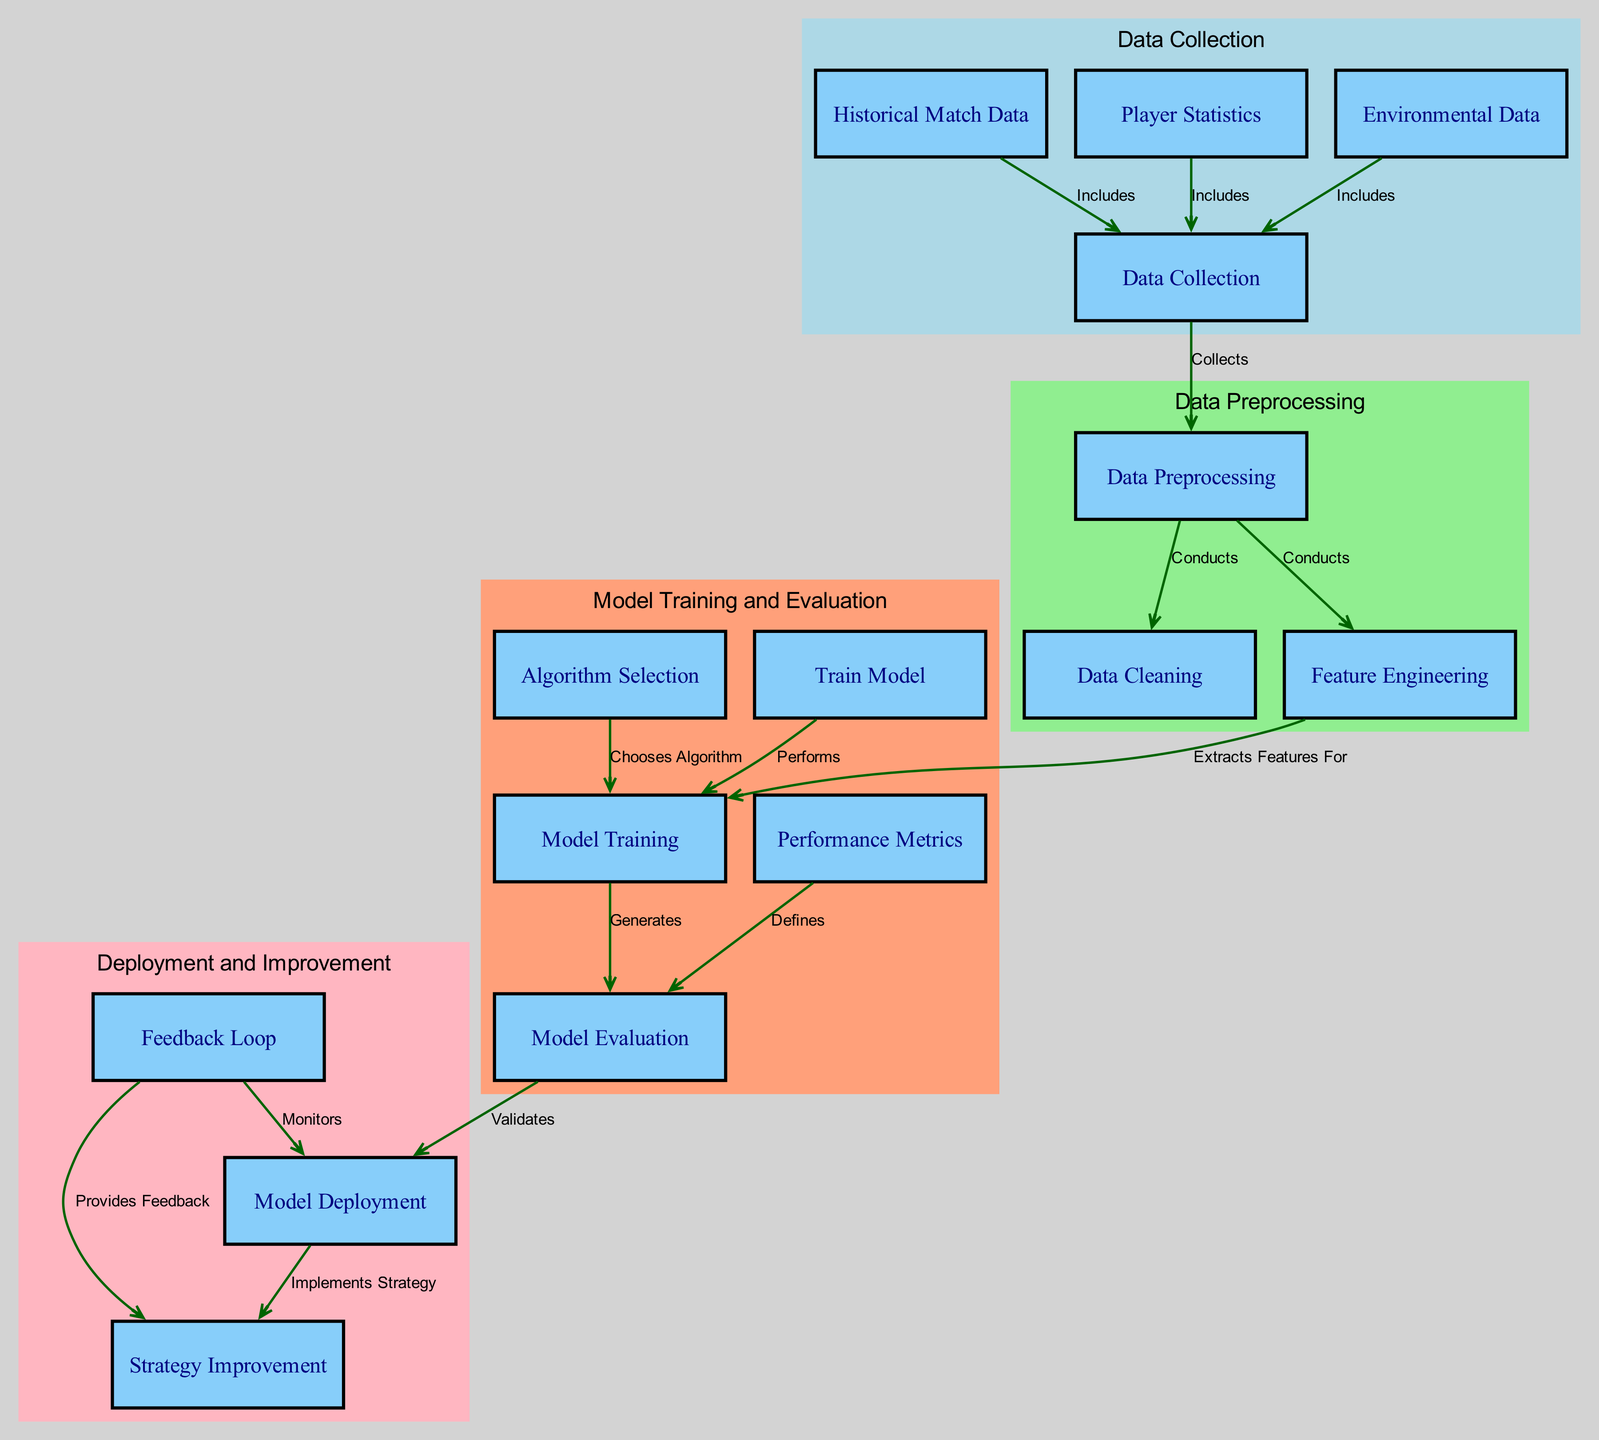What is the first step in the process? The first step in the process is Data Collection, which is where data from various sources like historical match data, player statistics, and environmental data is gathered.
Answer: Data Collection How many nodes are present in the diagram? The diagram contains a total of 14 nodes, each representing a specific stage in the machine learning process for game strategy improvement.
Answer: 14 Which node conducts data cleaning? The node that conducts data cleaning is Data Preprocessing, which is responsible for cleaning the raw data before feature extraction.
Answer: Data Preprocessing What node is responsible for selecting the algorithm? The node that is responsible for selecting the algorithm is Algorithm Selection; it chooses the appropriate algorithm for model training based on various factors.
Answer: Algorithm Selection What is the relationship between model evaluation and strategy improvement? Model Evaluation provides validation for the model and informs the Model Deployment, which implements the strategy. The Feedback Loop then provides information that leads to Strategy Improvement.
Answer: Feedback Loop How does environmental data relate to data collection? Environmental Data is included in the Data Collection process, meaning it contributes to the data that is collected for analysis.
Answer: Includes What are the output metrics defined by model evaluation? The output metrics defined by Model Evaluation are known as Performance Metrics, which evaluate how well the model performs against expected outcomes.
Answer: Performance Metrics What does the feedback loop provide information for? The Feedback Loop provides feedback information for Strategy Improvement, allowing for adjustments to be made based on model performance.
Answer: Strategy Improvement In which cluster does the train model node belong? The Train Model node belongs to the Model Training and Evaluation cluster, which focuses on training the model and assessing its performance.
Answer: Model Training and Evaluation 